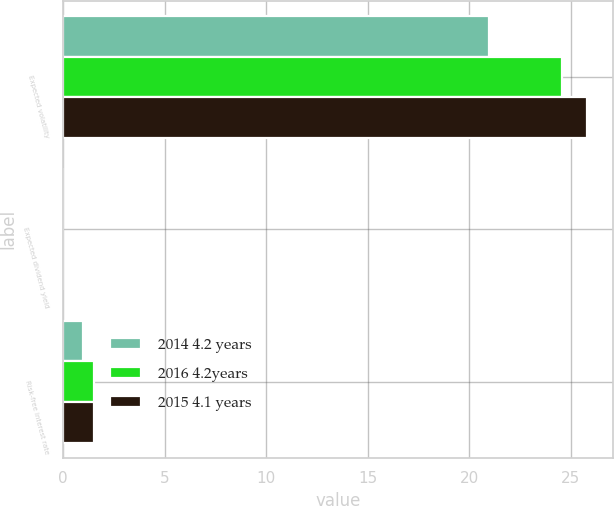<chart> <loc_0><loc_0><loc_500><loc_500><stacked_bar_chart><ecel><fcel>Expected volatility<fcel>Expected dividend yield<fcel>Risk-free interest rate<nl><fcel>2014 4.2 years<fcel>21<fcel>0<fcel>1<nl><fcel>2016 4.2years<fcel>24.6<fcel>0<fcel>1.5<nl><fcel>2015 4.1 years<fcel>25.8<fcel>0<fcel>1.5<nl></chart> 